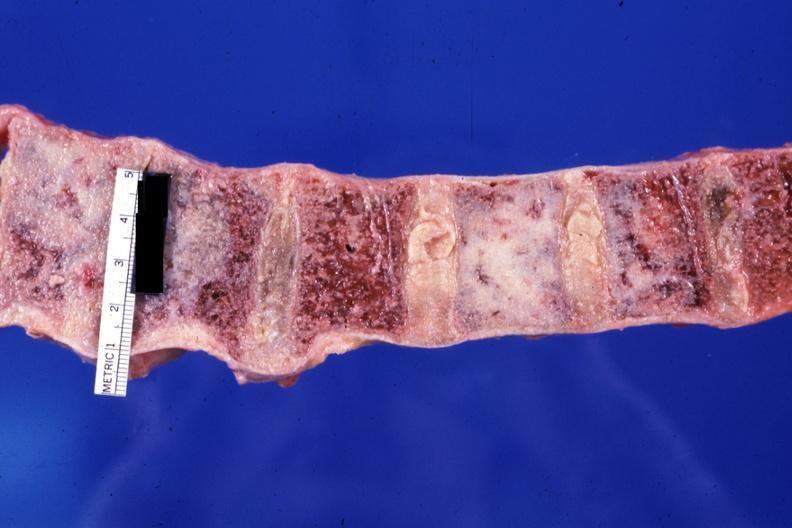does this image show looks like the ivory vertebra with breast carcinoma diagnosis not known at this time?
Answer the question using a single word or phrase. Yes 